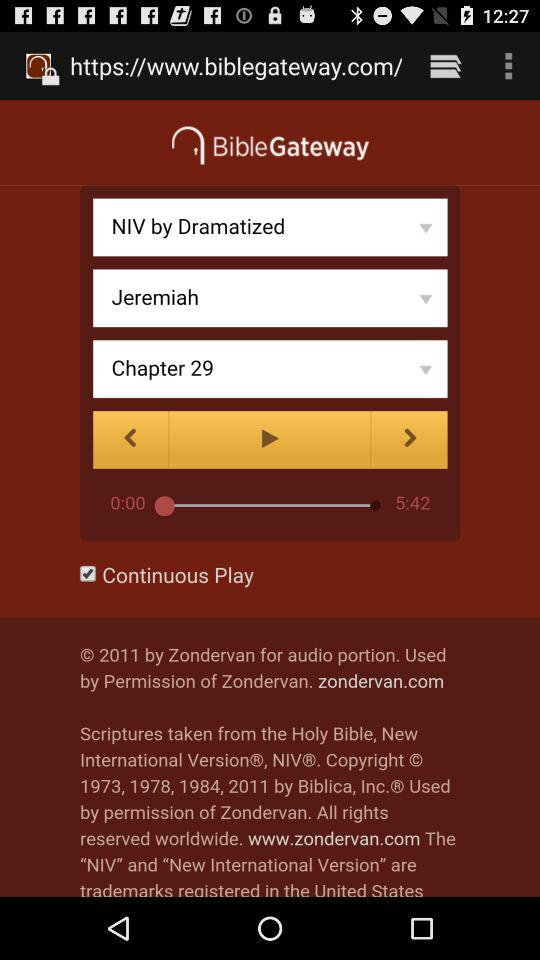What is the duration of Chapter 29? The duration is 5 minutes and 42 seconds. 